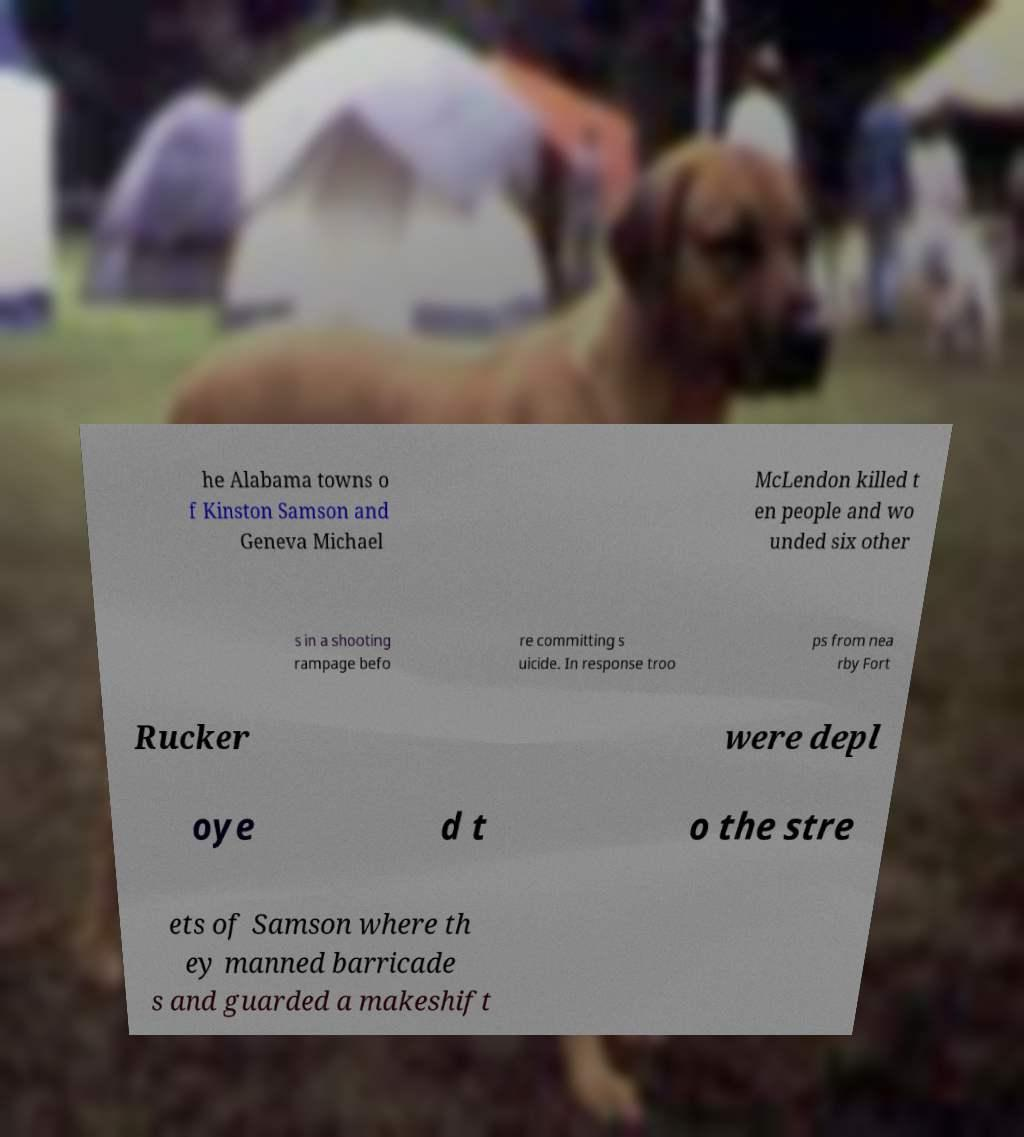Can you read and provide the text displayed in the image?This photo seems to have some interesting text. Can you extract and type it out for me? he Alabama towns o f Kinston Samson and Geneva Michael McLendon killed t en people and wo unded six other s in a shooting rampage befo re committing s uicide. In response troo ps from nea rby Fort Rucker were depl oye d t o the stre ets of Samson where th ey manned barricade s and guarded a makeshift 